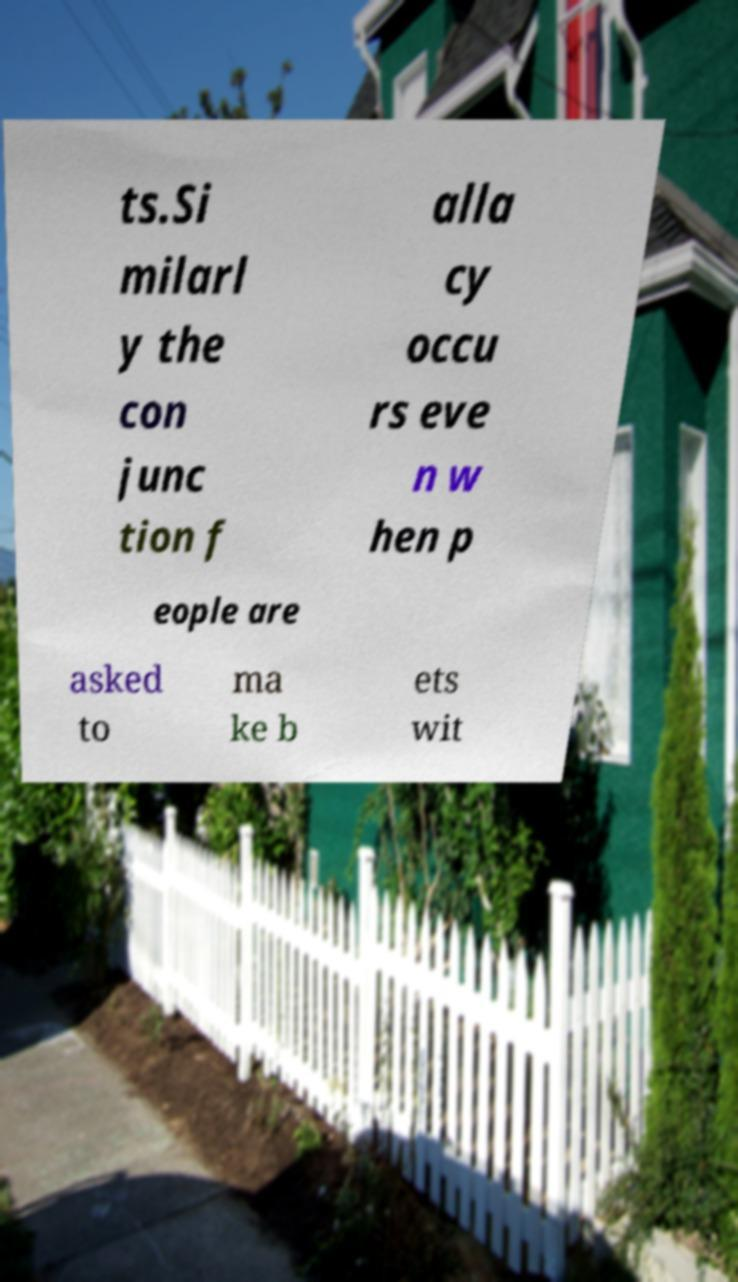Could you extract and type out the text from this image? ts.Si milarl y the con junc tion f alla cy occu rs eve n w hen p eople are asked to ma ke b ets wit 